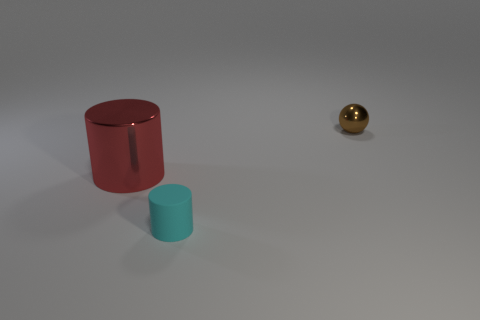Add 2 tiny cyan rubber objects. How many objects exist? 5 Subtract all cylinders. How many objects are left? 1 Add 2 brown metallic things. How many brown metallic things are left? 3 Add 3 matte cylinders. How many matte cylinders exist? 4 Subtract 0 red blocks. How many objects are left? 3 Subtract all metal cylinders. Subtract all large cylinders. How many objects are left? 1 